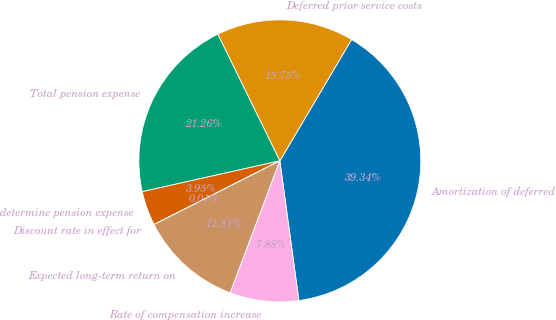<chart> <loc_0><loc_0><loc_500><loc_500><pie_chart><fcel>Amortization of deferred<fcel>Deferred prior service costs<fcel>Total pension expense<fcel>determine pension expense<fcel>Discount rate in effect for<fcel>Expected long-term return on<fcel>Rate of compensation increase<nl><fcel>39.34%<fcel>15.75%<fcel>21.26%<fcel>3.95%<fcel>0.01%<fcel>11.81%<fcel>7.88%<nl></chart> 